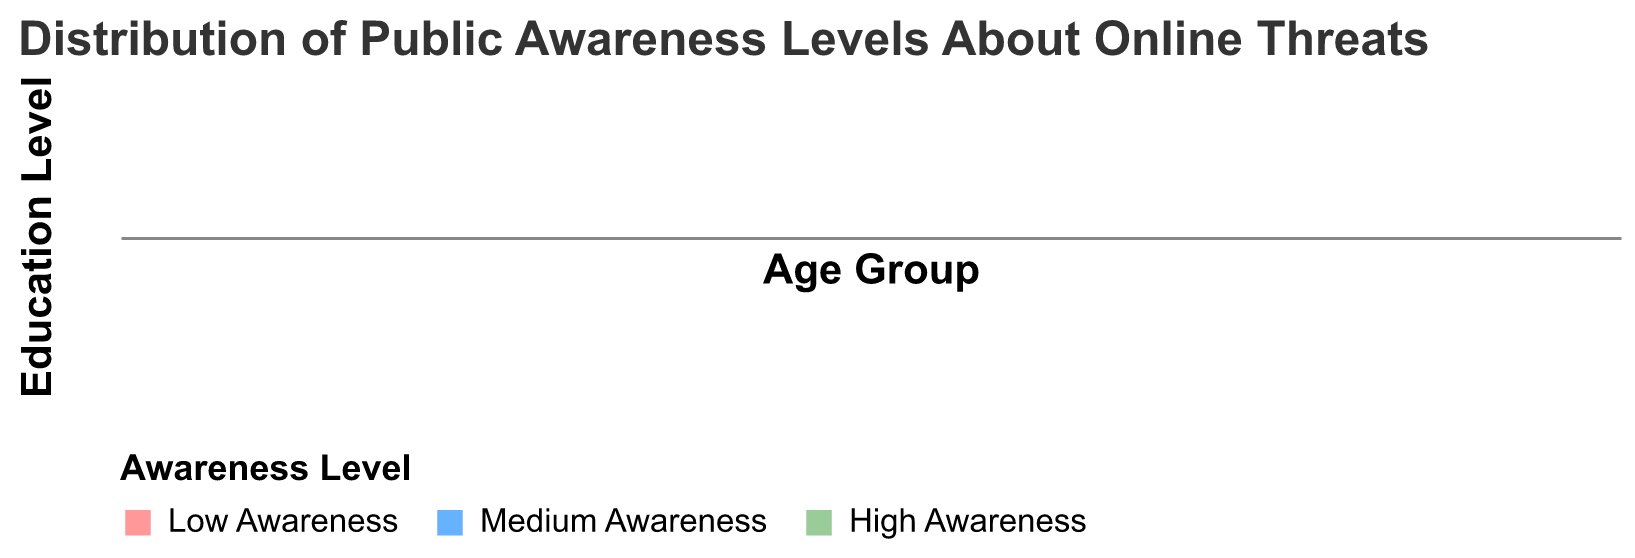What's the title of the figure? The title of the figure is usually at the top and is meant to provide an overview of what the plot represents. Here, the title text is "Distribution of Public Awareness Levels About Online Threats".
Answer: Distribution of Public Awareness Levels About Online Threats Which awareness level is depicted in green? The figure legend shows three awareness levels each with a different color. The color green corresponds to "High Awareness".
Answer: High Awareness In the 18-24 age group with a Bachelor's degree, which awareness level has the highest proportion? In the 18-24 age group with a Bachelor's degree, we need to compare the proportions of Low, Medium, and High Awareness. From the plot, the Medium Awareness has the highest proportion.
Answer: Medium Awareness Which age group and education level has the highest proportion of Low Awareness? To determine this, we look for the thickest bar segment corresponding to "Low Awareness" across all rows and columns. The "55+" age group with "High School" education level has the thickest (largest) segment for Low Awareness.
Answer: 55+ with High School For the 45-54 age group with Postgraduate education, what is the proportion difference between High Awareness and Low Awareness? First, find the proportion of High Awareness and Low Awareness for this group. High Awareness is 35%, and Low Awareness is 30%. The difference is obtained by subtracting 30% from 35%.
Answer: 5% Which age group and education level generally have the highest proportion of High Awareness? Observing the heights of the green segments across all rows and columns, the 18-24 age group with Postgraduate education has the highest proportion of High Awareness.
Answer: 18-24 with Postgraduate Comparing the 25-34 and 35-44 age groups with a Bachelor's degree, which group has a higher proportion of Medium Awareness? We need to compare the height of the blue segments for the two age groups under Bachelor's degree. The 25-34 age group has the higher proportion of Medium Awareness.
Answer: 25-34 How does the proportion of High Awareness change across age groups within the High School education level? For each age group within High School, observe the height of the green segments. It generally decreases as the age group increases.
Answer: Decreases as age increases Which education level tends to have the lowest Low Awareness across all age groups? By comparing the overall proportions of Low Awareness (red segments) across all education levels, the Postgraduate education level tends to have the lowest Low Awareness.
Answer: Postgraduate For the 55+ age group, compare the proportions of Medium Awareness between different education levels. Look at the height of the blue segments within the 55+ age group across three education levels. Both Bachelor's and Postgraduate have equal proportions, while High School has a slightly lower proportion.
Answer: Bachelor's and Postgraduate have equal, High School is lower 